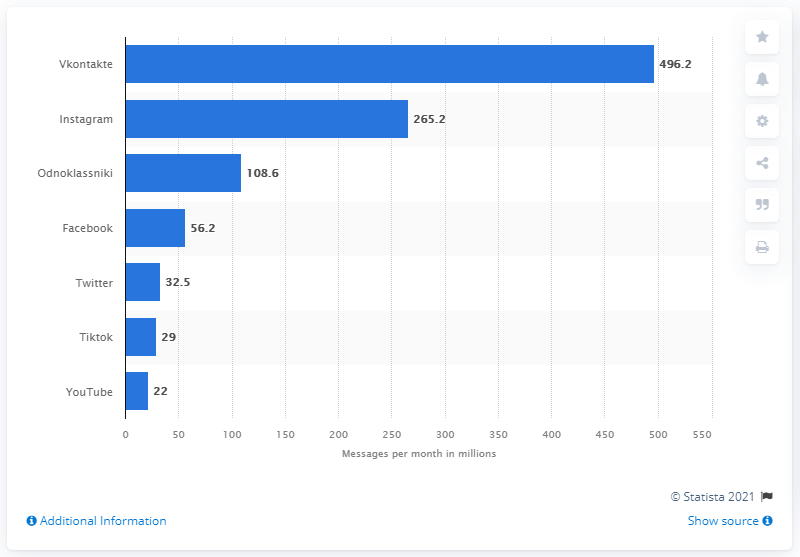Highlight a few significant elements in this photo. Instagram is the second most popular social network in Russia. Vkontakte is the social network with the highest ranking in Russia. 